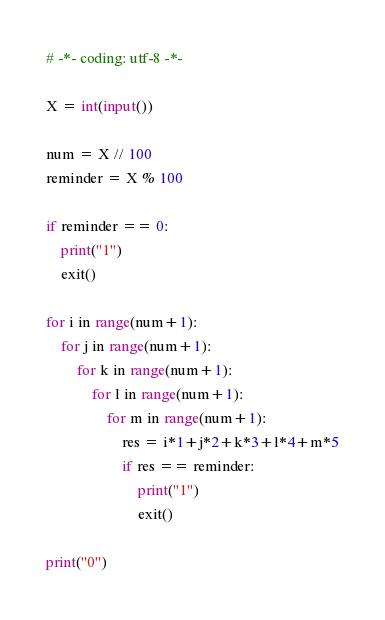Convert code to text. <code><loc_0><loc_0><loc_500><loc_500><_Python_># -*- coding: utf-8 -*-

X = int(input())

num = X // 100
reminder = X % 100

if reminder == 0:
    print("1")
    exit()

for i in range(num+1):
    for j in range(num+1):
        for k in range(num+1):
            for l in range(num+1):
                for m in range(num+1):
                    res = i*1+j*2+k*3+l*4+m*5
                    if res == reminder:
                        print("1")
                        exit()

print("0")
</code> 